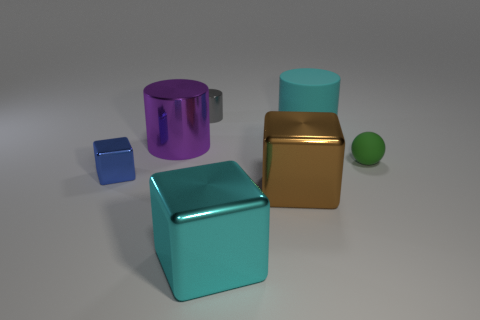Add 3 tiny blue blocks. How many objects exist? 10 Subtract all cubes. How many objects are left? 4 Add 5 tiny gray rubber objects. How many tiny gray rubber objects exist? 5 Subtract 0 red balls. How many objects are left? 7 Subtract all brown shiny cylinders. Subtract all large metal blocks. How many objects are left? 5 Add 4 blue shiny cubes. How many blue shiny cubes are left? 5 